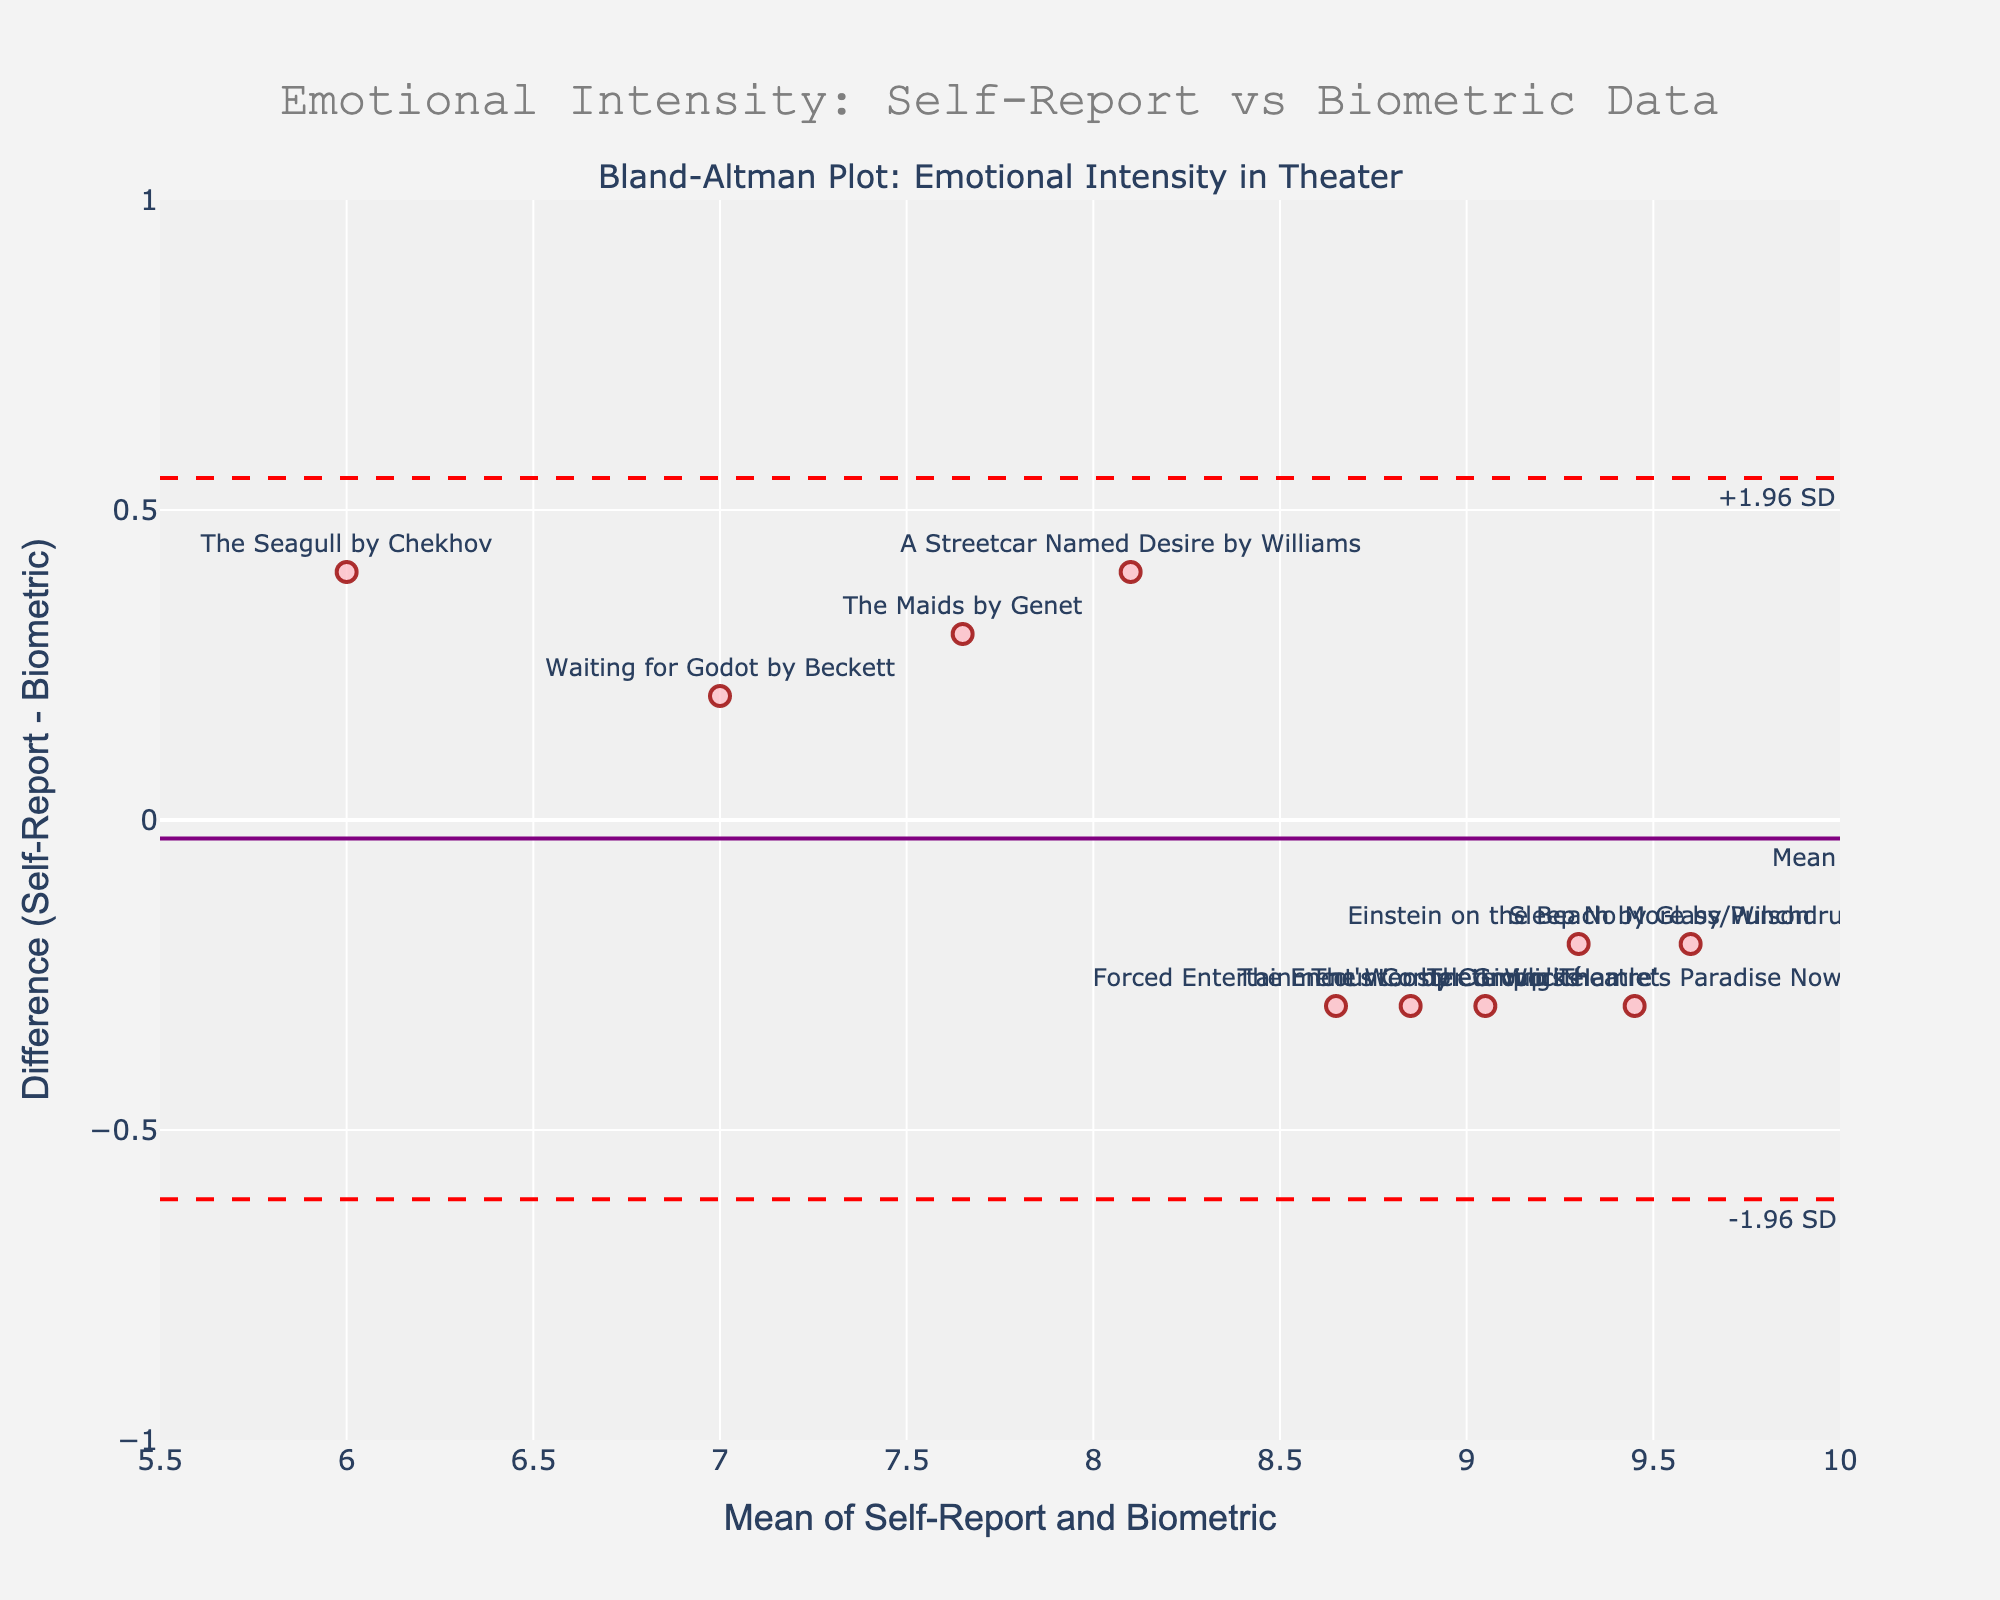What is the title of the figure? The title is located at the top of the figure and provides a brief description of what the plot represents. It reads "Emotional Intensity: Self-Report vs Biometric Data".
Answer: Emotional Intensity: Self-Report vs Biometric Data How many performances are represented in the figure? The number of data points can be determined by counting the individual markers on the scatter plot. Each marker corresponds to a performance labeled by its name.
Answer: 10 What are the x-axis and y-axis labels in the figure? The labels for both axes are found along the sides of the plot, indicating the variables being measured. The x-axis label is "Mean of Self-Report and Biometric" and the y-axis label is "Difference (Self-Report - Biometric)".
Answer: Mean of Self-Report and Biometric, Difference (Self-Report - Biometric) What do the solid and dashed horizontal lines represent? The solid horizontal line represents the mean difference between self-report and biometric data. The dashed lines represent the limits of agreement (mean difference plus and minus 1.96 times the standard deviation).
Answer: Mean difference, limits of agreement Which performance has the largest positive difference between self-report and biometric data? By looking at the positions of the markers on the y-axis, we can identify the performance with the highest positive difference value. "A Streetcar Named Desire" by Williams is the highest.
Answer: "A Streetcar Named Desire" by Williams What is the purpose of the annotations "+1.96 SD" and "-1.96 SD" on the plot? These annotations indicate the upper and lower limits of agreement, which are crucial for understanding the range within which most differences between self-report and biometric data are expected to lie.
Answer: Limits of agreement What is the mean difference value represented by the solid line? The solid line on the y-axis indicates the average difference between self-reported and biometric data across all performances. This value is around the center of the plot's y-axis, which is approximately 0.
Answer: 0 How do the experimental performances compare to the traditional ones in terms of biometric data accuracy? By examining where the experimental (avant-garde) and traditional performances fall relative to the x-axis, we can infer that experimental performances are closer to the zero difference line, suggesting higher accuracy in biometric records.
Answer: Experimental performances have higher biometric accuracy Which performance has the smallest difference between self-report and biometric data? The smallest difference (closest to zero) is identified by locating the point closest to the y-axis line where the difference is minimal. "The Wooster Group's Hamlet" by Beckett has the smallest difference.
Answer: "The Wooster Group's Hamlet" Does the plot suggest any systematic bias in self-reporting? Understanding bias involves assessing whether most points lie predominantly above or below the mean difference line. The plot shows data points scattered fairly evenly around the mean line, suggesting no systematic bias.
Answer: No systematic bias 